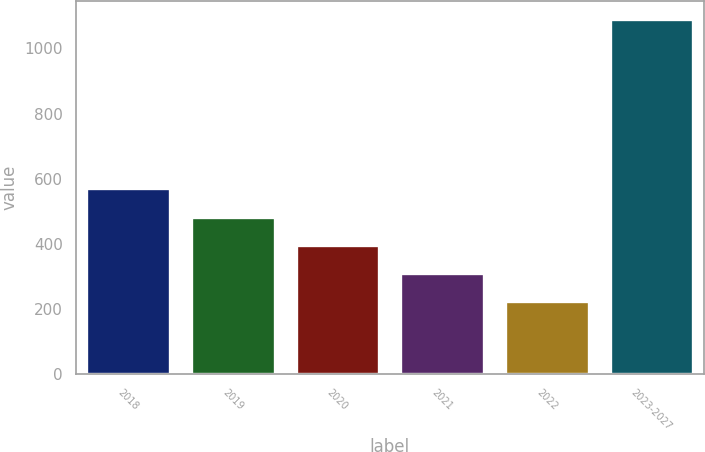Convert chart. <chart><loc_0><loc_0><loc_500><loc_500><bar_chart><fcel>2018<fcel>2019<fcel>2020<fcel>2021<fcel>2022<fcel>2023-2027<nl><fcel>570.4<fcel>483.8<fcel>397.2<fcel>310.6<fcel>224<fcel>1090<nl></chart> 